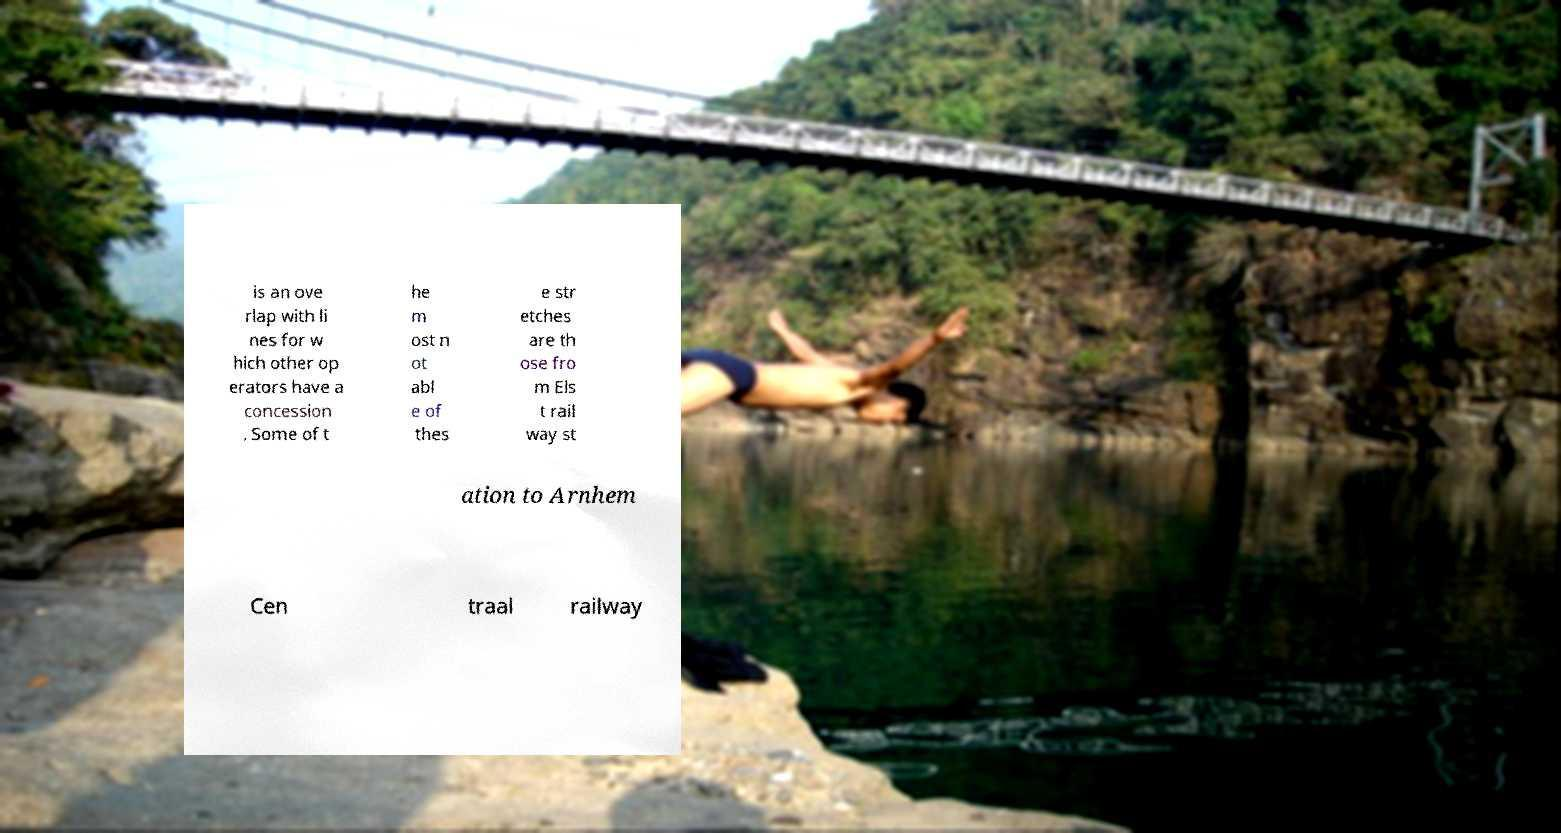For documentation purposes, I need the text within this image transcribed. Could you provide that? is an ove rlap with li nes for w hich other op erators have a concession . Some of t he m ost n ot abl e of thes e str etches are th ose fro m Els t rail way st ation to Arnhem Cen traal railway 